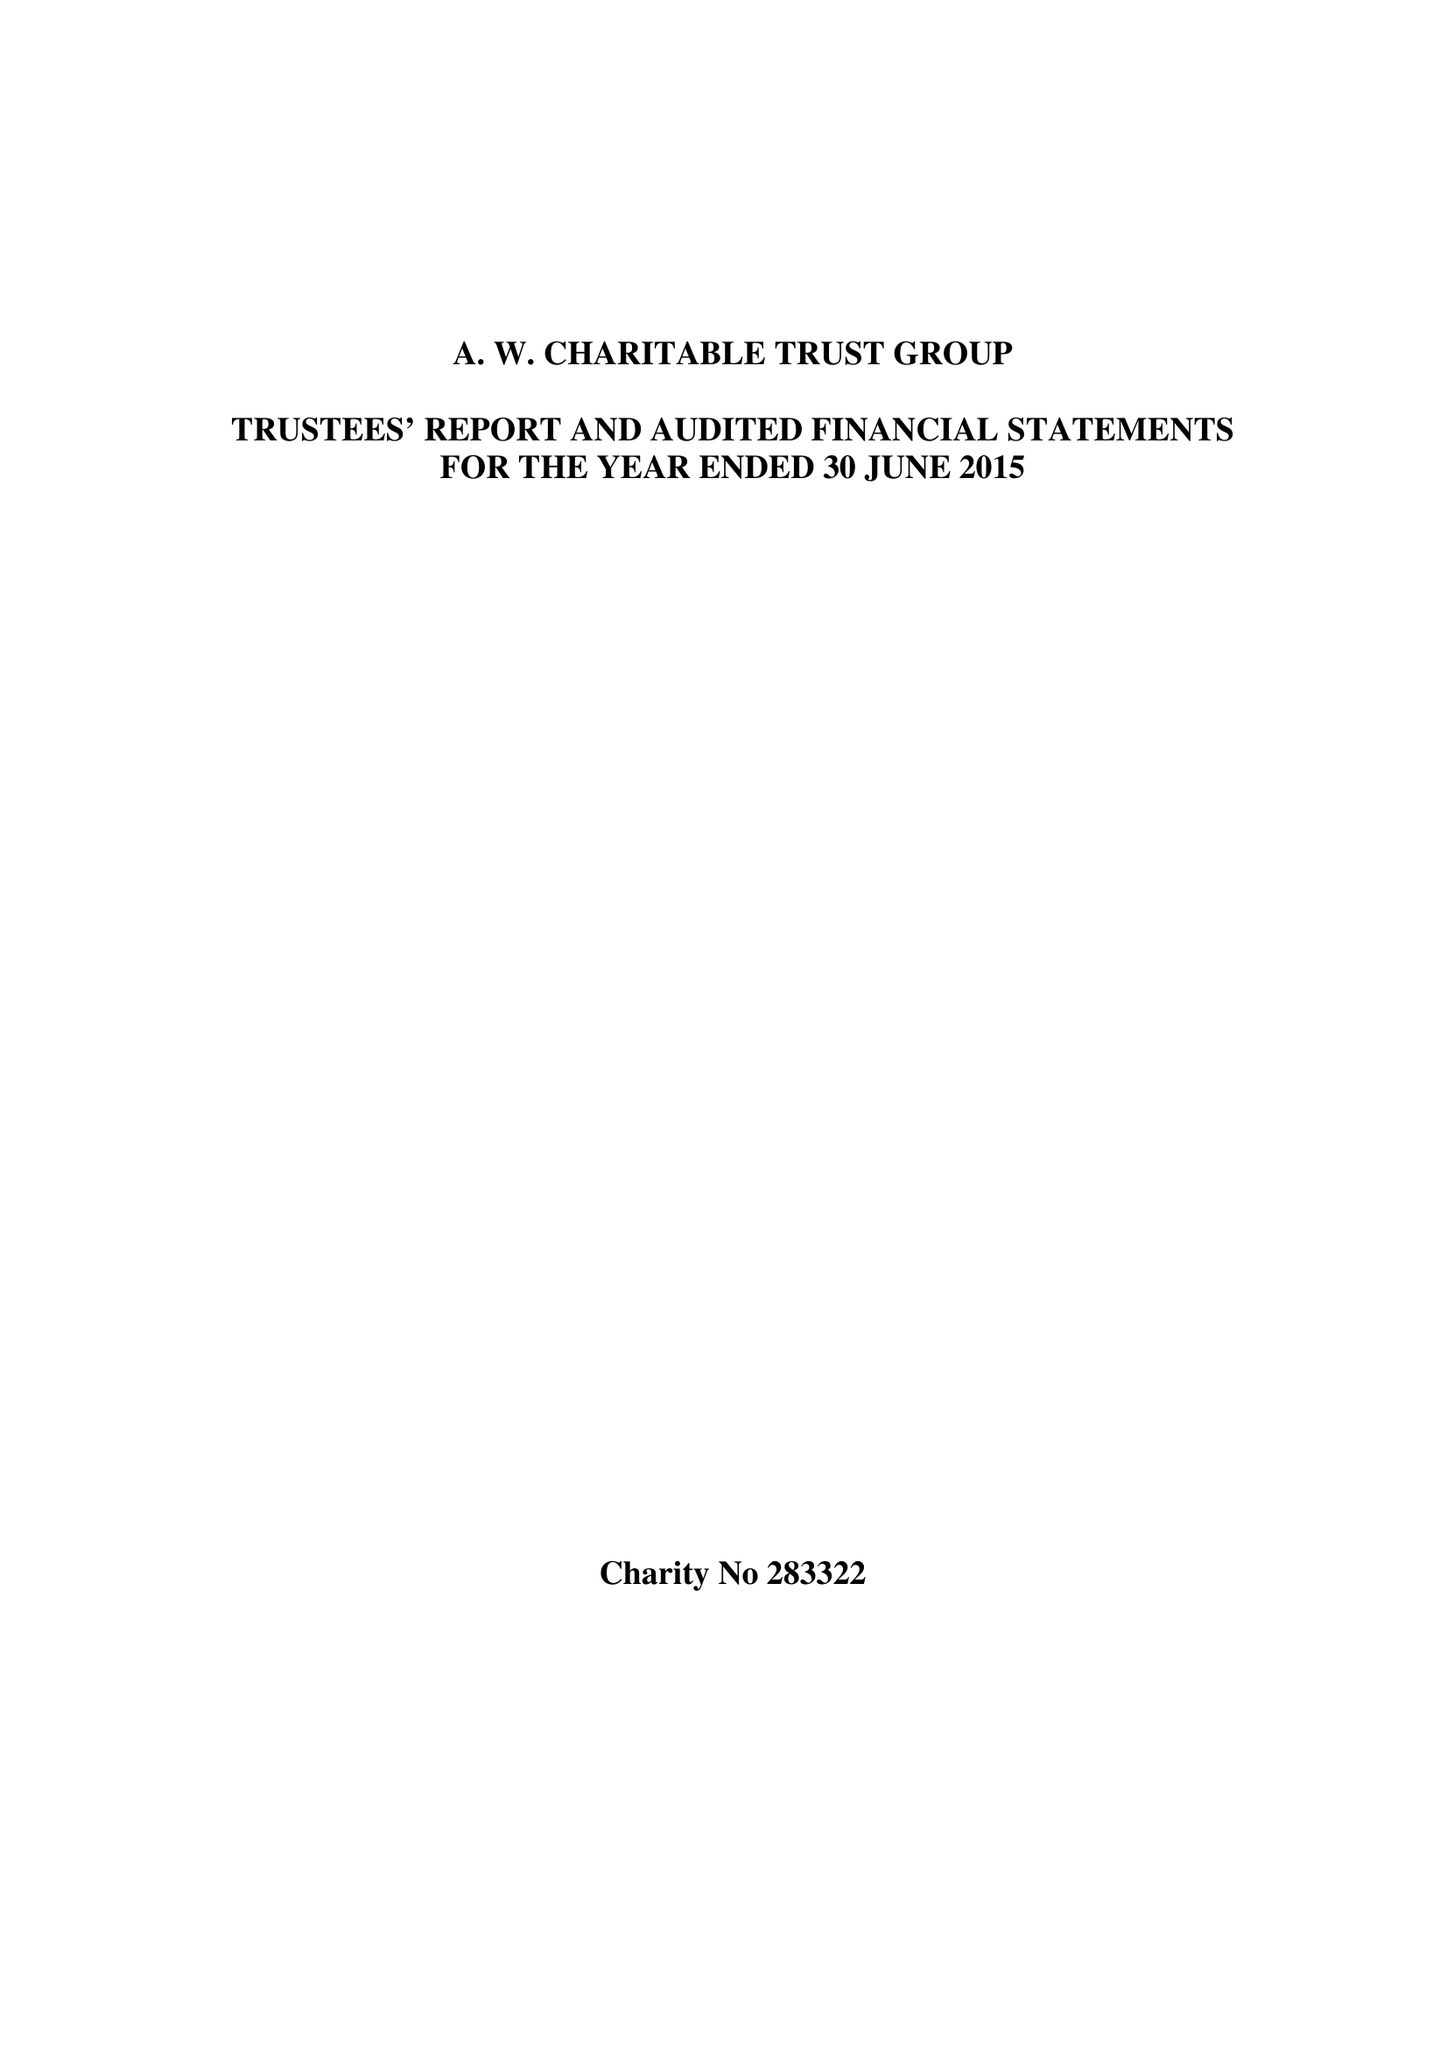What is the value for the report_date?
Answer the question using a single word or phrase. 2015-06-30 